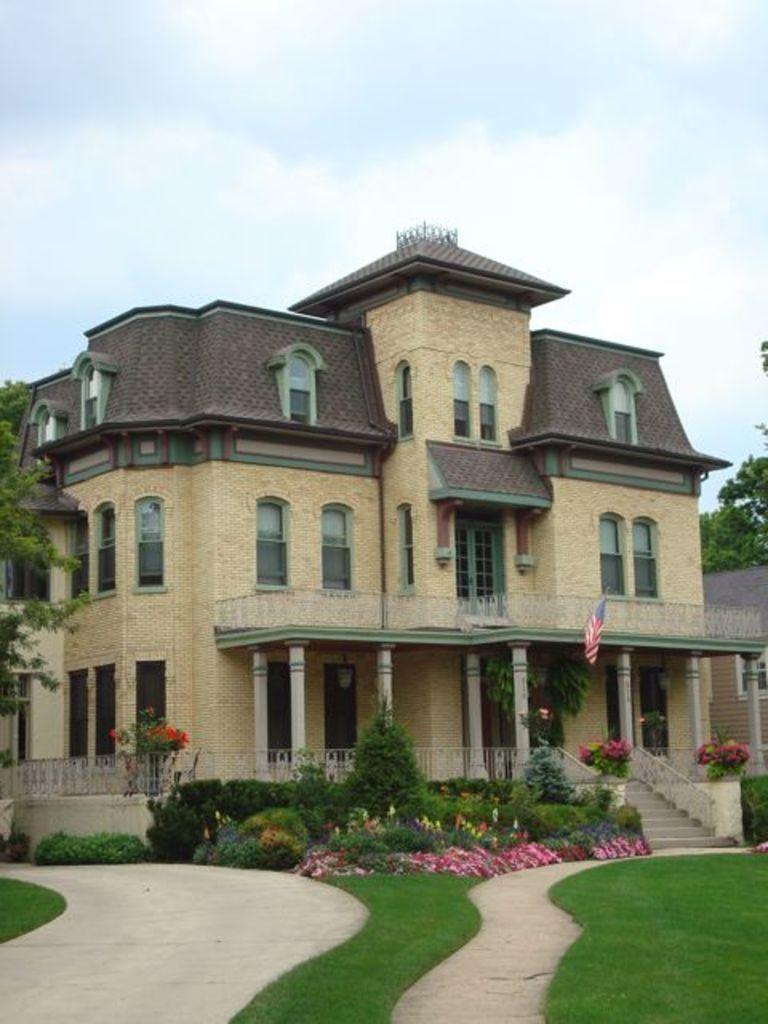Describe this image in one or two sentences. In the middle there is a building, on the left side there are trees. At the top it is the cloudy sky. 